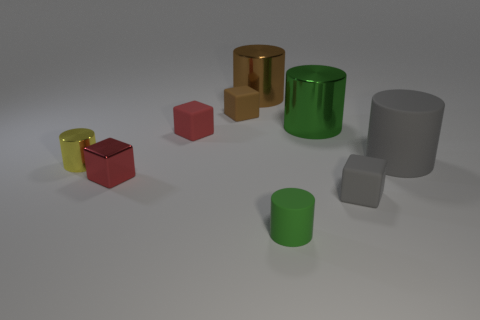Subtract all green matte cylinders. How many cylinders are left? 4 Subtract 1 cylinders. How many cylinders are left? 4 Subtract all gray blocks. How many blocks are left? 3 Subtract 0 purple cubes. How many objects are left? 9 Subtract all cubes. How many objects are left? 5 Subtract all cyan cylinders. Subtract all red balls. How many cylinders are left? 5 Subtract all blue cylinders. How many red cubes are left? 2 Subtract all yellow rubber spheres. Subtract all rubber cubes. How many objects are left? 6 Add 2 small yellow metallic things. How many small yellow metallic things are left? 3 Add 1 small metallic things. How many small metallic things exist? 3 